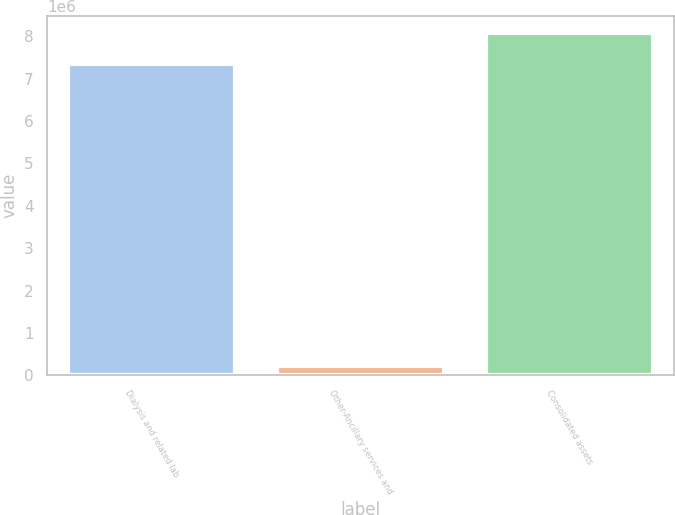Convert chart to OTSL. <chart><loc_0><loc_0><loc_500><loc_500><bar_chart><fcel>Dialysis and related lab<fcel>Other-Ancillary services and<fcel>Consolidated assets<nl><fcel>7.33424e+06<fcel>224001<fcel>8.06766e+06<nl></chart> 